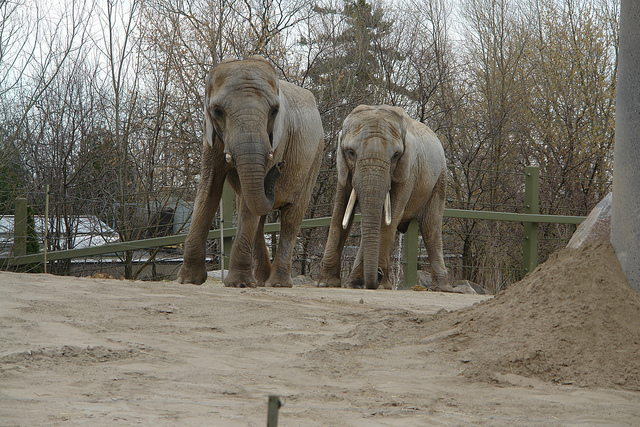<image>Are they mother and son? I don't know if they are mother and son. Are they mother and son? I don't know if they are mother and son. It is possible that they are, but I can't be sure. 